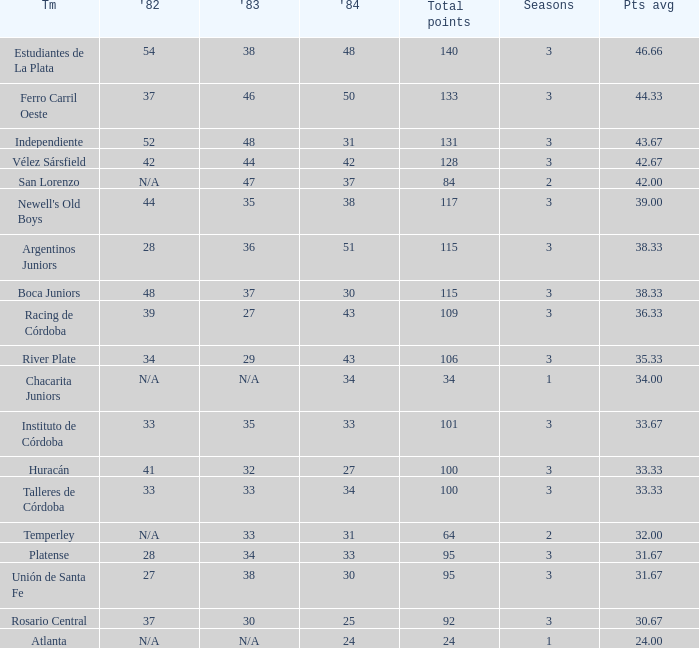What is the number of seasons for the team with a total fewer than 24? None. 